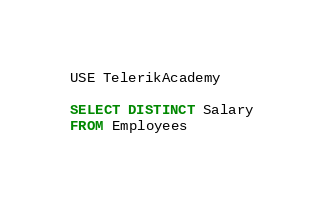<code> <loc_0><loc_0><loc_500><loc_500><_SQL_>USE TelerikAcademy

SELECT DISTINCT Salary
FROM Employees</code> 